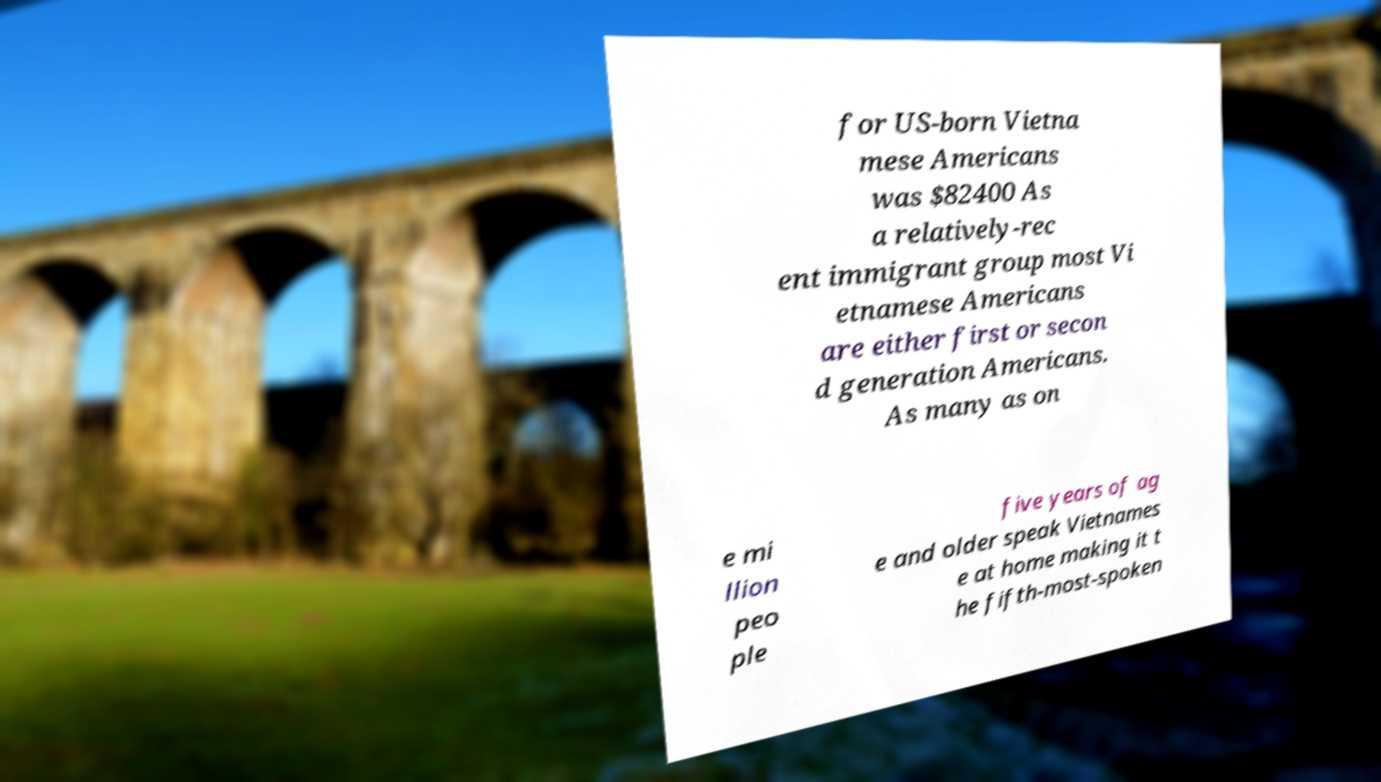For documentation purposes, I need the text within this image transcribed. Could you provide that? for US-born Vietna mese Americans was $82400 As a relatively-rec ent immigrant group most Vi etnamese Americans are either first or secon d generation Americans. As many as on e mi llion peo ple five years of ag e and older speak Vietnames e at home making it t he fifth-most-spoken 